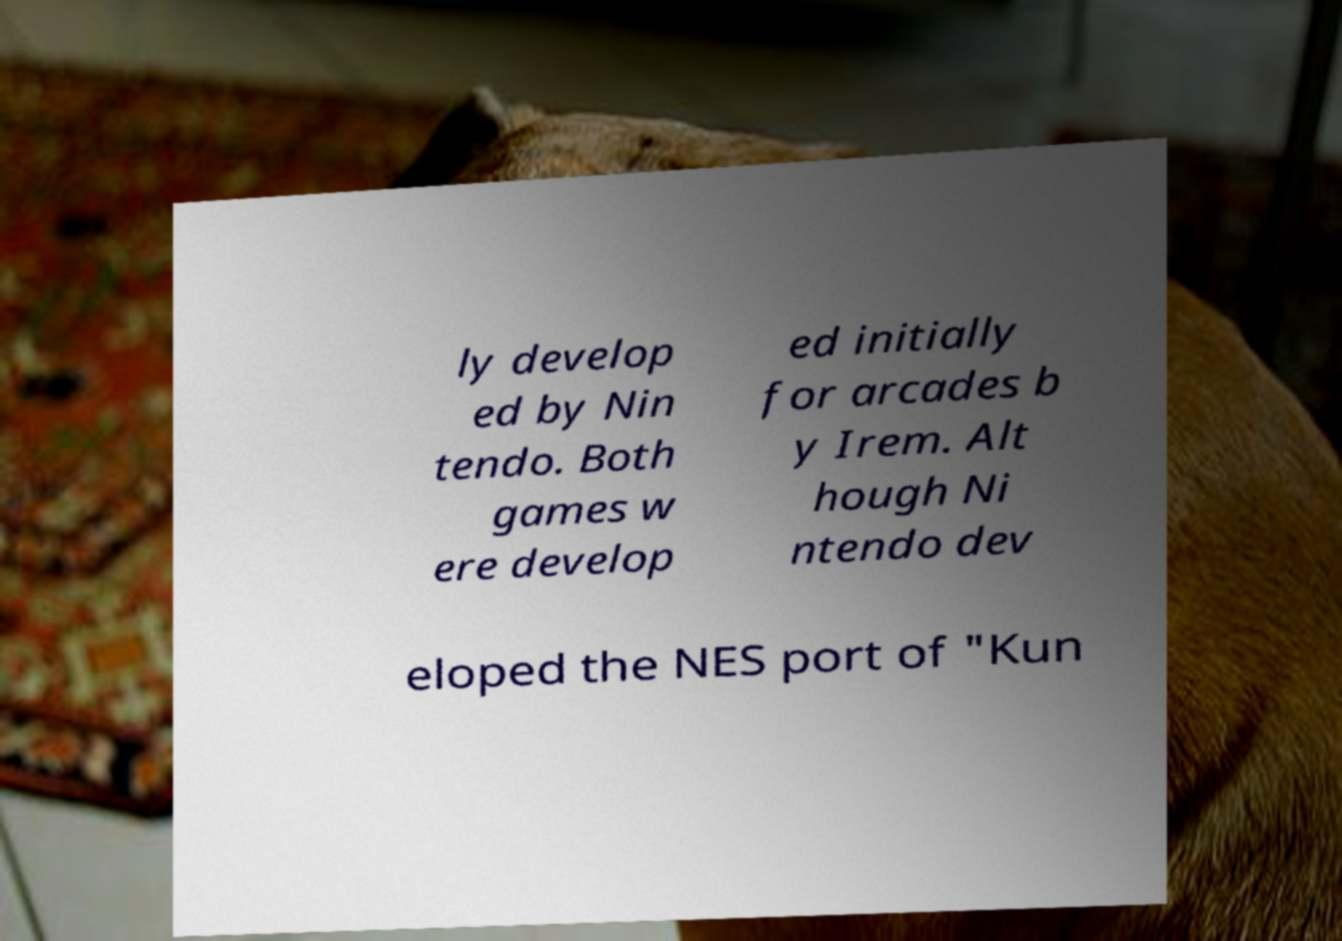Could you extract and type out the text from this image? ly develop ed by Nin tendo. Both games w ere develop ed initially for arcades b y Irem. Alt hough Ni ntendo dev eloped the NES port of "Kun 